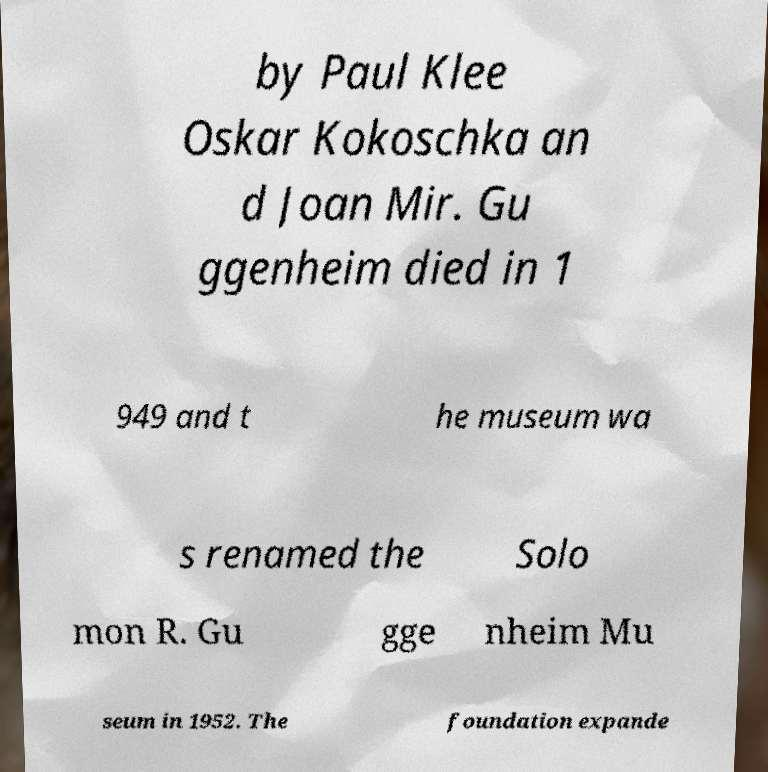Can you accurately transcribe the text from the provided image for me? by Paul Klee Oskar Kokoschka an d Joan Mir. Gu ggenheim died in 1 949 and t he museum wa s renamed the Solo mon R. Gu gge nheim Mu seum in 1952. The foundation expande 